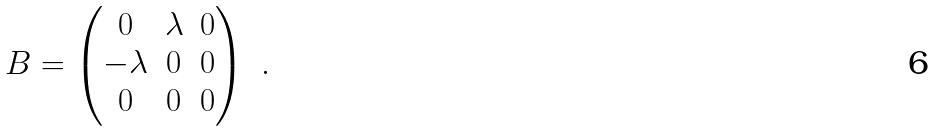<formula> <loc_0><loc_0><loc_500><loc_500>B = \begin{pmatrix} 0 & \lambda & 0 \\ - \lambda & 0 & 0 \\ 0 & 0 & 0 \end{pmatrix} \ .</formula> 